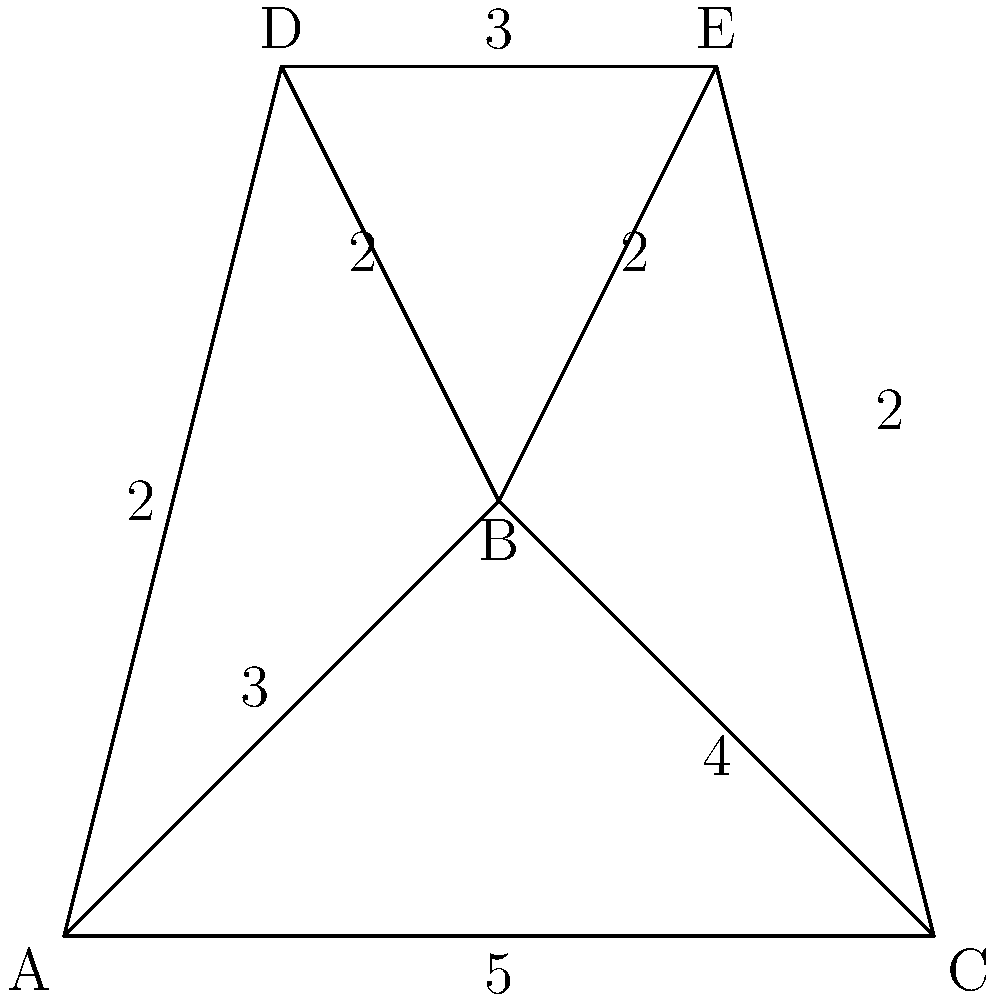In the given network diagram, find the shortest path from node A to node C. What is the total weight of this path? To find the shortest path from A to C, we need to consider all possible paths and their total weights:

1. Path A-C directly:
   Weight = 5

2. Path A-B-C:
   Weight = 3 + 4 = 7

3. Path A-D-E-C:
   Weight = 2 + 3 + 2 = 7

4. Path A-B-E-C:
   Weight = 3 + 2 + 2 = 7

5. Path A-B-D-E-C:
   Weight = 3 + 2 + 3 + 2 = 10

6. Path A-D-B-C:
   Weight = 2 + 2 + 4 = 8

The shortest path is the one with the smallest total weight. In this case, it's the direct path A-C with a weight of 5.
Answer: 5 